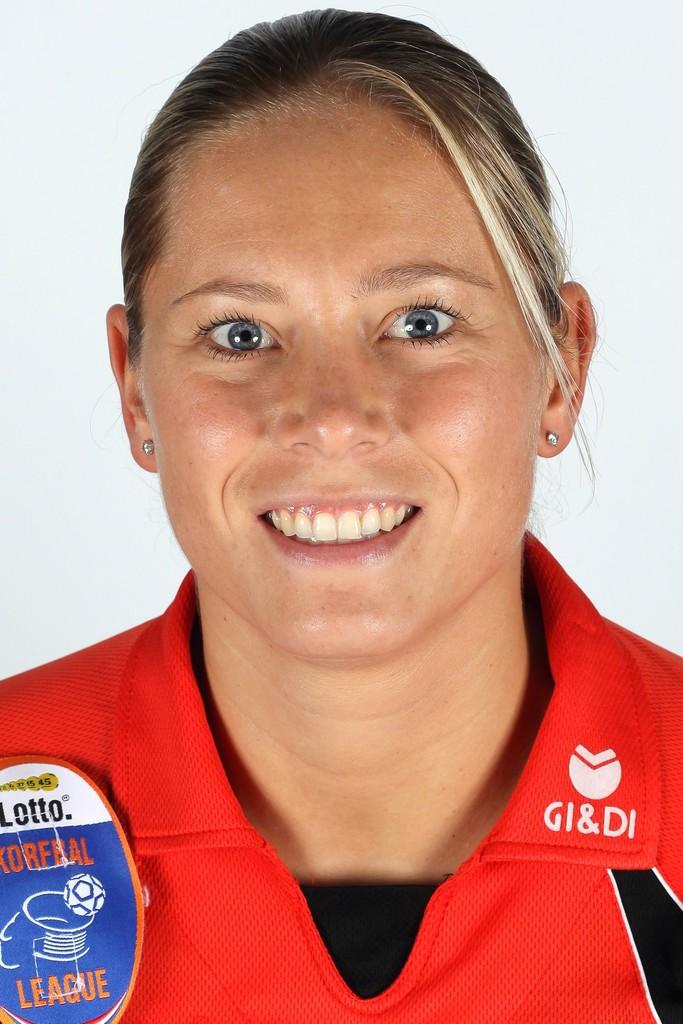What company makes the shirt she's wearing?
Offer a very short reply. Gi&di. 